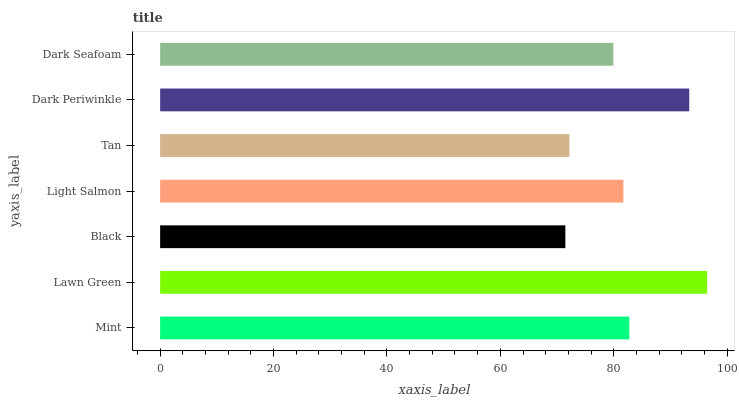Is Black the minimum?
Answer yes or no. Yes. Is Lawn Green the maximum?
Answer yes or no. Yes. Is Lawn Green the minimum?
Answer yes or no. No. Is Black the maximum?
Answer yes or no. No. Is Lawn Green greater than Black?
Answer yes or no. Yes. Is Black less than Lawn Green?
Answer yes or no. Yes. Is Black greater than Lawn Green?
Answer yes or no. No. Is Lawn Green less than Black?
Answer yes or no. No. Is Light Salmon the high median?
Answer yes or no. Yes. Is Light Salmon the low median?
Answer yes or no. Yes. Is Mint the high median?
Answer yes or no. No. Is Dark Seafoam the low median?
Answer yes or no. No. 